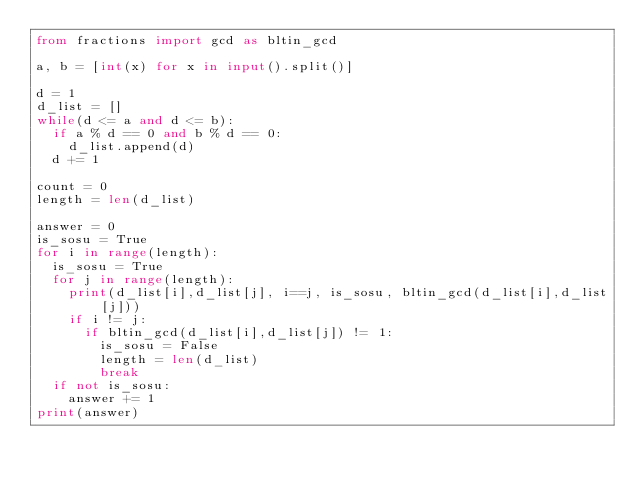Convert code to text. <code><loc_0><loc_0><loc_500><loc_500><_Python_>from fractions import gcd as bltin_gcd

a, b = [int(x) for x in input().split()]

d = 1
d_list = []
while(d <= a and d <= b):
  if a % d == 0 and b % d == 0:
    d_list.append(d)
  d += 1

count = 0
length = len(d_list)

answer = 0
is_sosu = True
for i in range(length):
  is_sosu = True
  for j in range(length):
    print(d_list[i],d_list[j], i==j, is_sosu, bltin_gcd(d_list[i],d_list[j]))
    if i != j:
      if bltin_gcd(d_list[i],d_list[j]) != 1:
        is_sosu = False
        length = len(d_list)
        break
  if not is_sosu:
    answer += 1
print(answer)</code> 